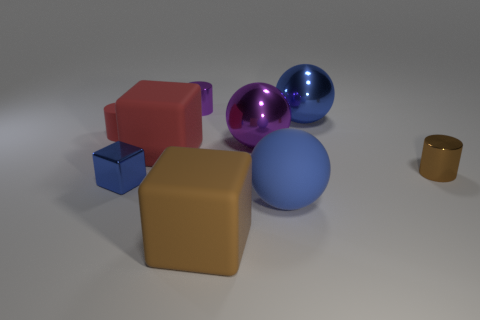Is the tiny purple object the same shape as the blue rubber object?
Your answer should be very brief. No. What number of blocks are large brown matte objects or big matte things?
Ensure brevity in your answer.  2. There is another big sphere that is the same color as the large rubber sphere; what material is it?
Offer a very short reply. Metal. There is a matte ball; does it have the same color as the tiny shiny cylinder on the right side of the brown block?
Give a very brief answer. No. The metal block is what color?
Offer a very short reply. Blue. How many things are either brown rubber things or big red shiny things?
Your answer should be compact. 1. What material is the other cube that is the same size as the brown cube?
Your response must be concise. Rubber. There is a blue shiny object to the left of the blue metallic sphere; what is its size?
Your response must be concise. Small. What is the material of the purple ball?
Offer a very short reply. Metal. What number of objects are either large blue metal things right of the large brown block or small objects that are behind the red matte cube?
Ensure brevity in your answer.  3. 